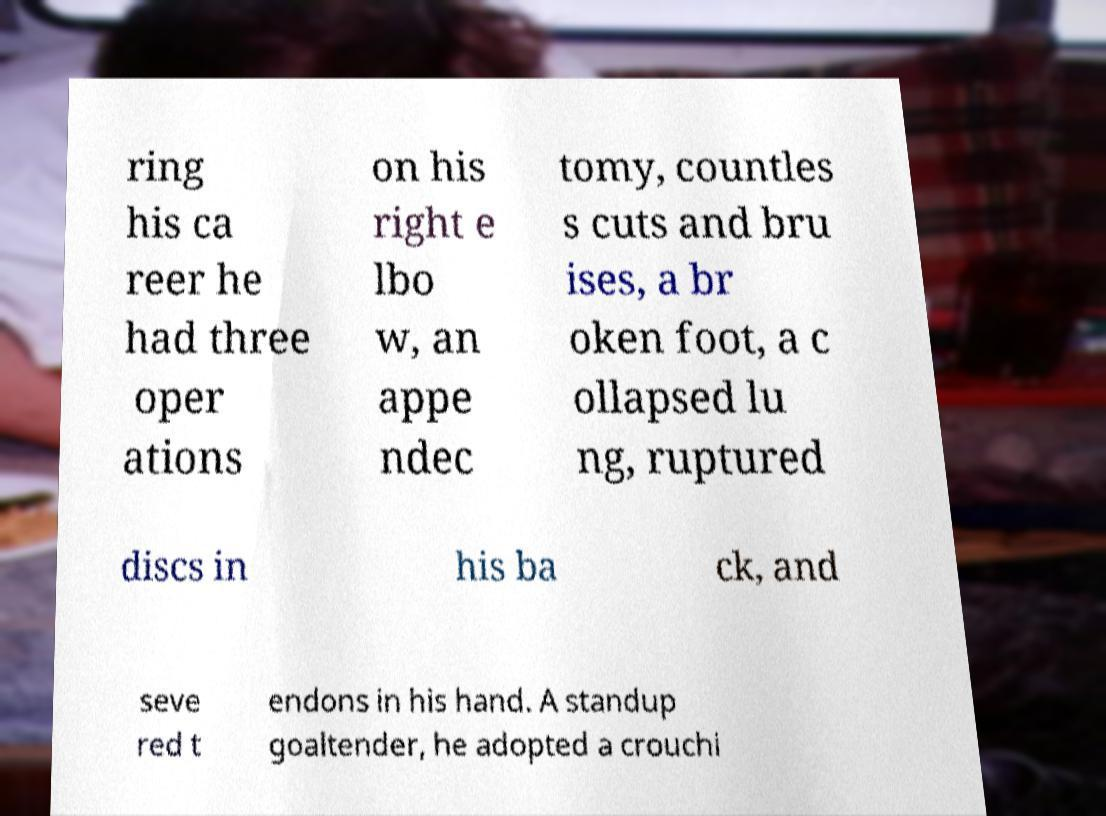Can you accurately transcribe the text from the provided image for me? ring his ca reer he had three oper ations on his right e lbo w, an appe ndec tomy, countles s cuts and bru ises, a br oken foot, a c ollapsed lu ng, ruptured discs in his ba ck, and seve red t endons in his hand. A standup goaltender, he adopted a crouchi 